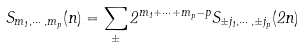<formula> <loc_0><loc_0><loc_500><loc_500>S _ { m _ { 1 } , \cdots , m _ { p } } ( n ) = \sum _ { \pm } 2 ^ { m _ { 1 } + \cdots + m _ { p } - p } S _ { \pm j _ { 1 } , \cdots , \pm j _ { p } } ( 2 n )</formula> 